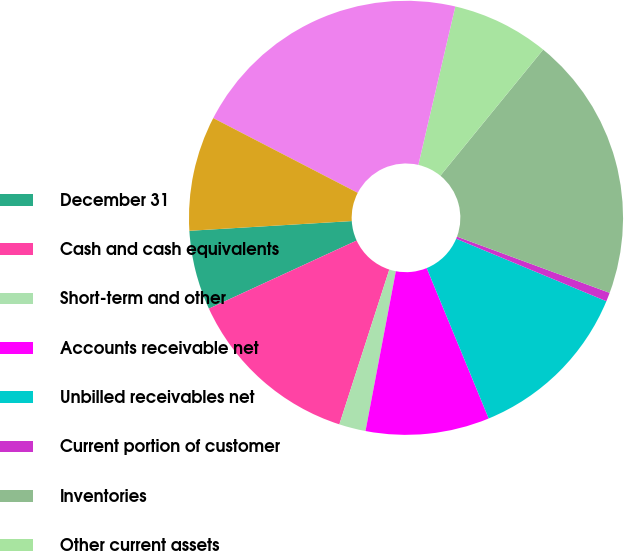Convert chart. <chart><loc_0><loc_0><loc_500><loc_500><pie_chart><fcel>December 31<fcel>Cash and cash equivalents<fcel>Short-term and other<fcel>Accounts receivable net<fcel>Unbilled receivables net<fcel>Current portion of customer<fcel>Inventories<fcel>Other current assets<fcel>Total current assets<fcel>Customer financing net<nl><fcel>5.92%<fcel>13.16%<fcel>1.98%<fcel>9.21%<fcel>12.5%<fcel>0.66%<fcel>19.73%<fcel>7.24%<fcel>21.05%<fcel>8.55%<nl></chart> 